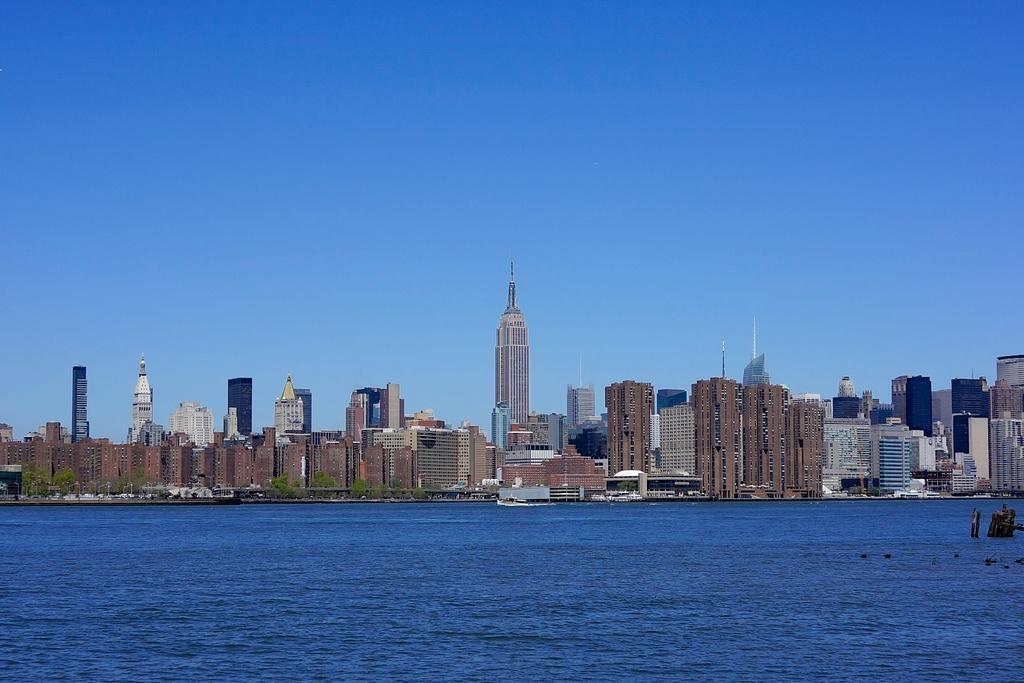What type of structures can be seen in the image? There are buildings in the image. What natural elements are present in the image? There are trees and water visible in the image. Can you describe the objects in the water? There are objects in the water, but their specific nature is not mentioned in the facts. What part of the natural environment is visible in the image? The sky is visible in the image. What type of carriage can be seen transporting sugar in the image? There is no carriage or sugar present in the image. What is the hammer being used for in the image? There is no hammer present in the image. 